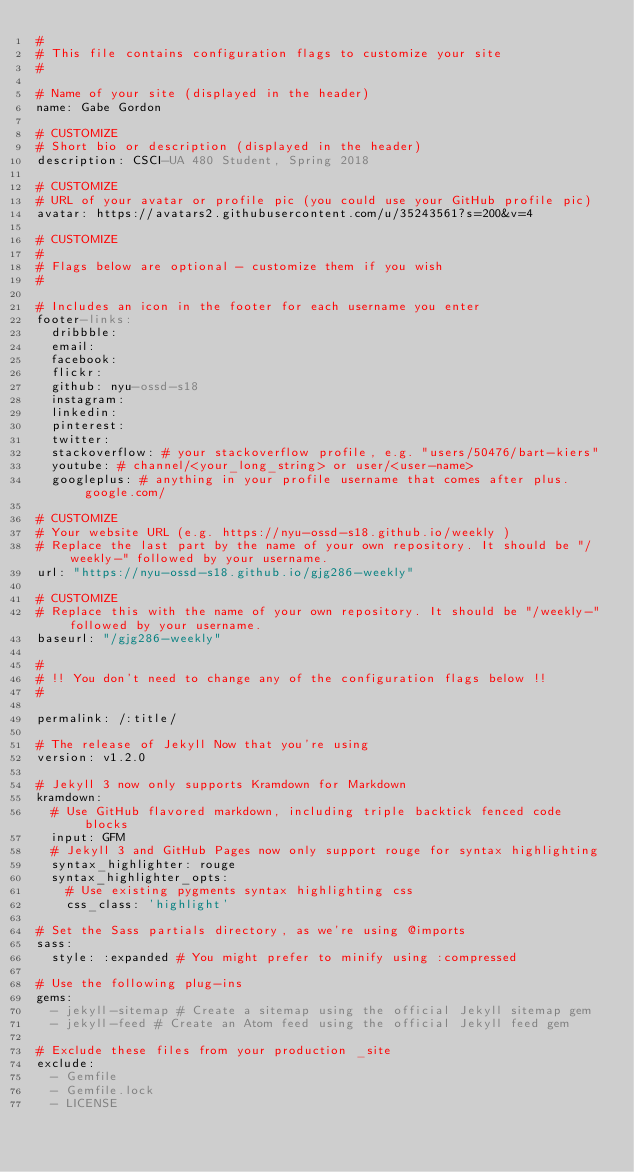Convert code to text. <code><loc_0><loc_0><loc_500><loc_500><_YAML_>#
# This file contains configuration flags to customize your site
#

# Name of your site (displayed in the header)
name: Gabe Gordon

# CUSTOMIZE
# Short bio or description (displayed in the header)
description: CSCI-UA 480 Student, Spring 2018

# CUSTOMIZE
# URL of your avatar or profile pic (you could use your GitHub profile pic)
avatar: https://avatars2.githubusercontent.com/u/35243561?s=200&v=4

# CUSTOMIZE
#
# Flags below are optional - customize them if you wish 
#

# Includes an icon in the footer for each username you enter
footer-links:
  dribbble:
  email:
  facebook:
  flickr:
  github: nyu-ossd-s18
  instagram:
  linkedin:
  pinterest:
  twitter: 
  stackoverflow: # your stackoverflow profile, e.g. "users/50476/bart-kiers"
  youtube: # channel/<your_long_string> or user/<user-name>
  googleplus: # anything in your profile username that comes after plus.google.com/

# CUSTOMIZE
# Your website URL (e.g. https://nyu-ossd-s18.github.io/weekly )
# Replace the last part by the name of your own repository. It should be "/weekly-" followed by your username. 
url: "https://nyu-ossd-s18.github.io/gjg286-weekly" 

# CUSTOMIZE
# Replace this with the name of your own repository. It should be "/weekly-" followed by your username.
baseurl: "/gjg286-weekly"

#
# !! You don't need to change any of the configuration flags below !!
#

permalink: /:title/

# The release of Jekyll Now that you're using
version: v1.2.0

# Jekyll 3 now only supports Kramdown for Markdown
kramdown:
  # Use GitHub flavored markdown, including triple backtick fenced code blocks
  input: GFM
  # Jekyll 3 and GitHub Pages now only support rouge for syntax highlighting
  syntax_highlighter: rouge
  syntax_highlighter_opts:
    # Use existing pygments syntax highlighting css
    css_class: 'highlight'

# Set the Sass partials directory, as we're using @imports
sass:
  style: :expanded # You might prefer to minify using :compressed

# Use the following plug-ins
gems:
  - jekyll-sitemap # Create a sitemap using the official Jekyll sitemap gem
  - jekyll-feed # Create an Atom feed using the official Jekyll feed gem

# Exclude these files from your production _site
exclude:
  - Gemfile
  - Gemfile.lock
  - LICENSE
</code> 